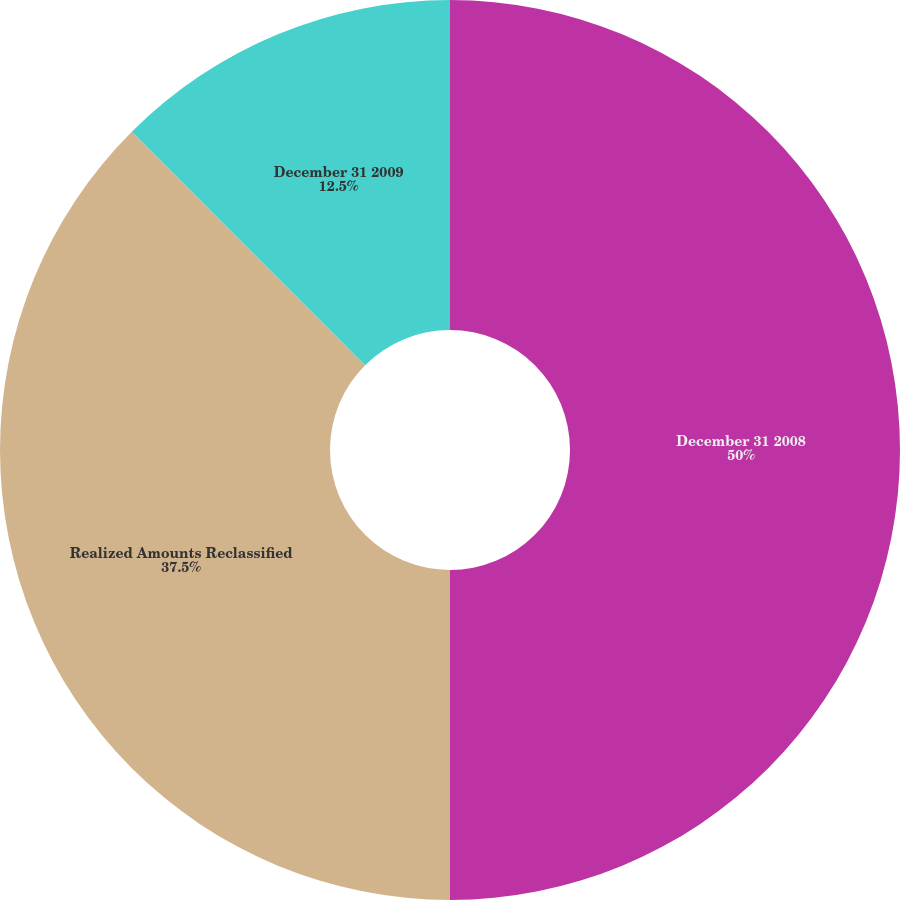<chart> <loc_0><loc_0><loc_500><loc_500><pie_chart><fcel>December 31 2008<fcel>Realized Amounts Reclassified<fcel>December 31 2009<nl><fcel>50.0%<fcel>37.5%<fcel>12.5%<nl></chart> 